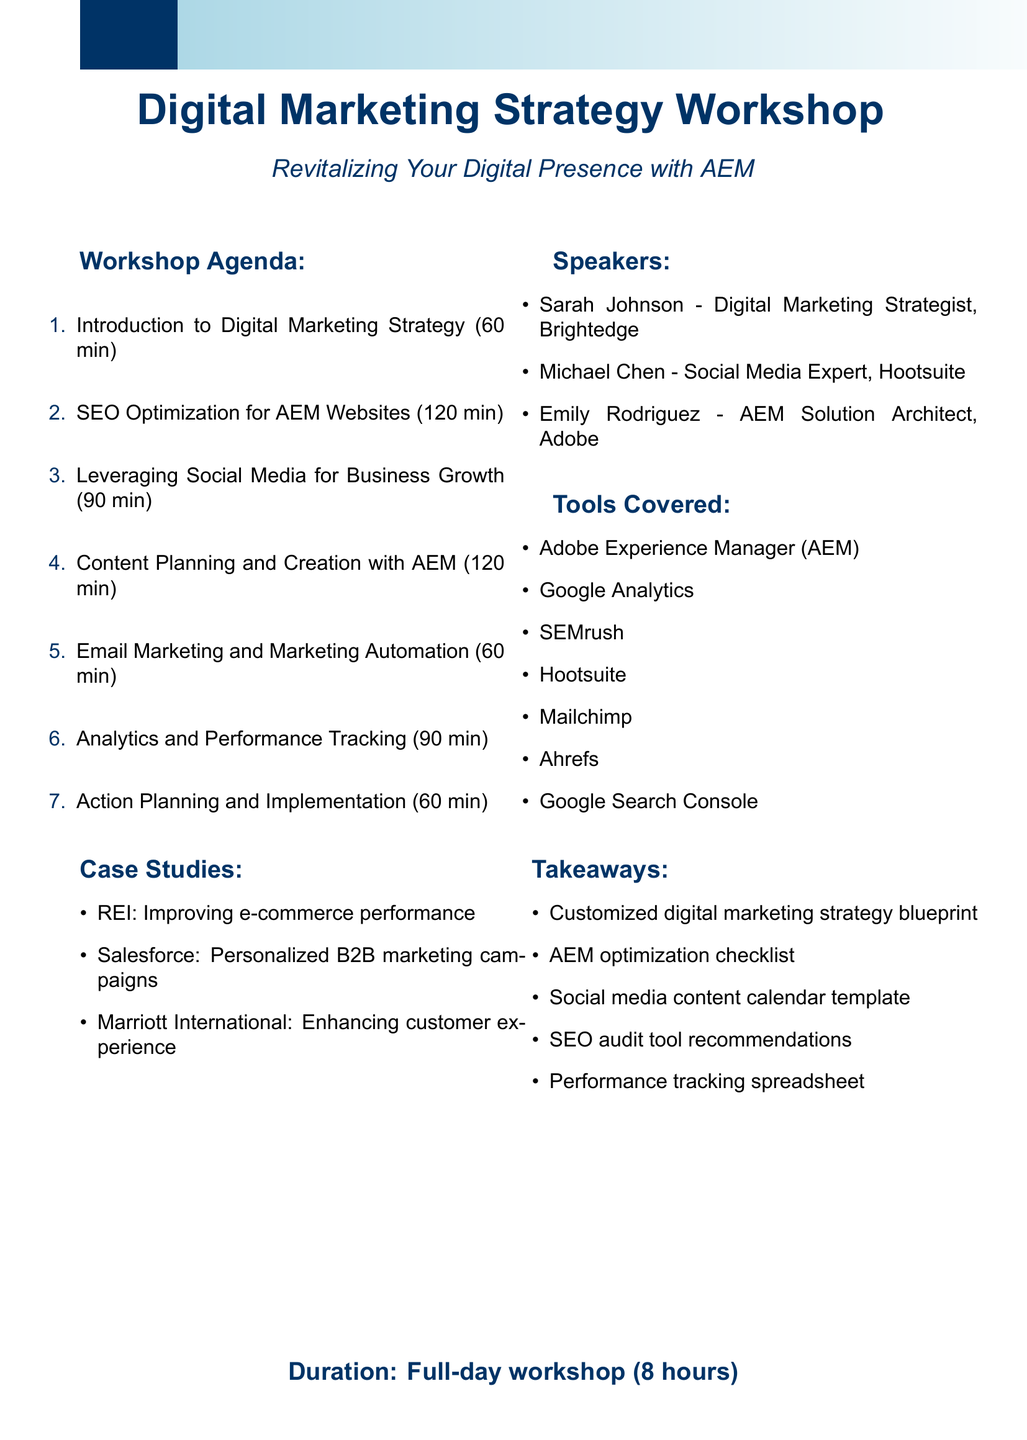what is the title of the workshop? The title of the workshop is stated at the beginning of the document as "Revitalizing Your Digital Presence: A Comprehensive Digital Marketing Strategy Workshop for AEM Users."
Answer: Revitalizing Your Digital Presence: A Comprehensive Digital Marketing Strategy Workshop for AEM Users how long is the workshop? The duration of the workshop is mentioned clearly at the end of the document.
Answer: Full-day workshop (8 hours) how many modules are there in total? The document enumerates the modules listed under the agenda section.
Answer: seven who is the speaker for SEO optimization? The document lists the speakers along with their expertise, identifying the relevant speaker for SEO.
Answer: Sarah Johnson which tool is mentioned for email marketing? The tools covered section includes specific mentions relevant to different marketing channels, including one for email marketing.
Answer: Mailchimp how many minutes is allocated for content planning and creation? The module breakdown specifies the time allocated to each module, including content planning and creation.
Answer: 120 minutes which company is cited for improving e-commerce performance? The case studies section provides examples of companies, and one example focuses on e-commerce performance.
Answer: REI what is one of the takeaways from the workshop? The takeaways are explicitly listed toward the end of the document, providing examples of outputs attendees can expect.
Answer: Customized digital marketing strategy blueprint 